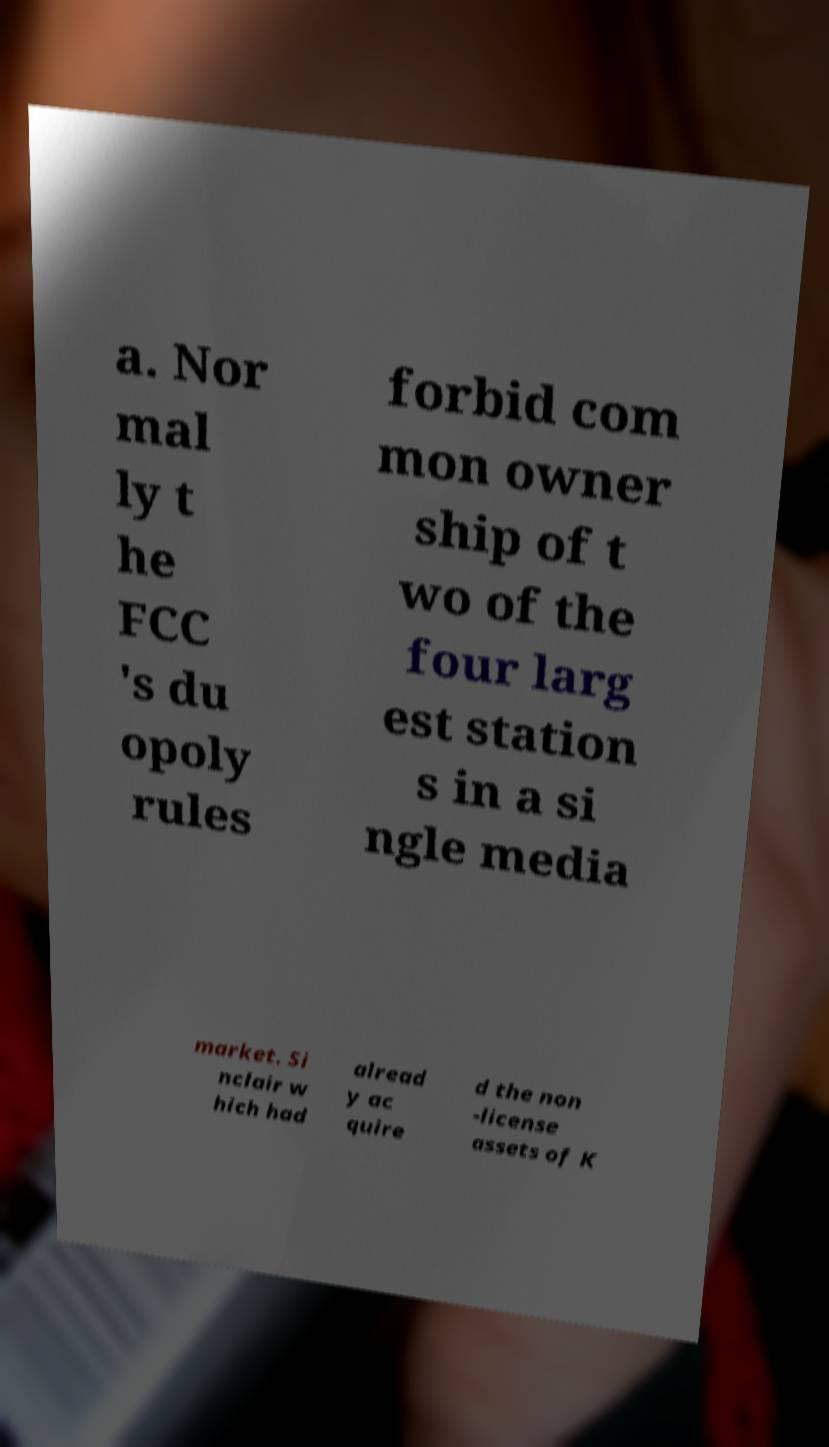There's text embedded in this image that I need extracted. Can you transcribe it verbatim? a. Nor mal ly t he FCC 's du opoly rules forbid com mon owner ship of t wo of the four larg est station s in a si ngle media market. Si nclair w hich had alread y ac quire d the non -license assets of K 